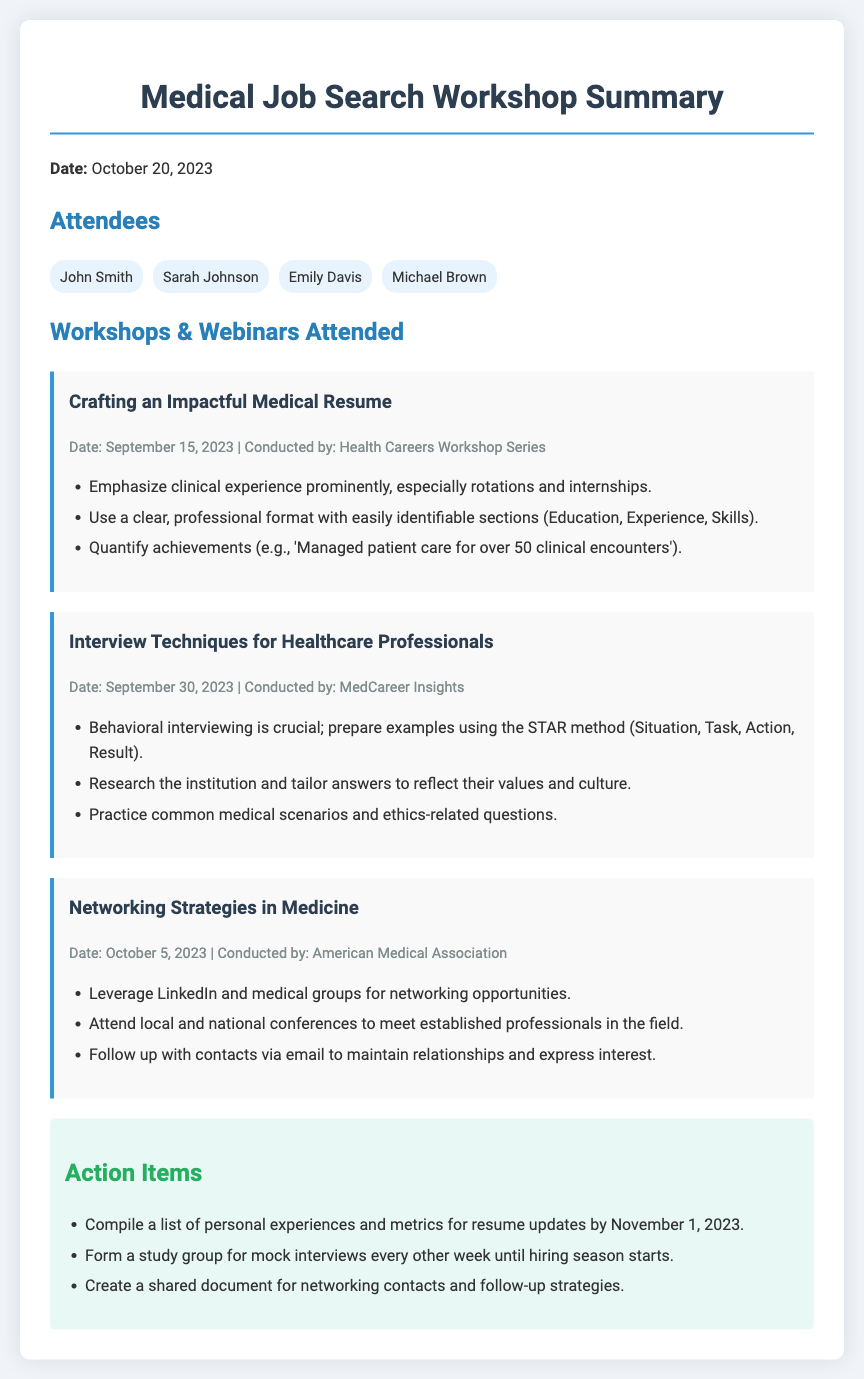What is the date of the workshop summary? The date is explicitly stated at the beginning of the document, which is October 20, 2023.
Answer: October 20, 2023 Who conducted the "Crafting an Impactful Medical Resume" workshop? The document specifies the organization that conducted this workshop as the Health Careers Workshop Series.
Answer: Health Careers Workshop Series What is one key takeaway from the "Interview Techniques for Healthcare Professionals"? The document lists several key points from the workshop, one of which emphasizes the STAR method for behavioral interviewing.
Answer: STAR method How many workshops or webinars were attended according to the document? By counting the workshops listed, there are three workshops mentioned in the document.
Answer: Three What is one of the action items mentioned in the document? The action items section outlines specific tasks, one of which is to compile a list of personal experiences and metrics for resume updates.
Answer: Compile a list of personal experiences When was the "Networking Strategies in Medicine" workshop held? The date of this workshop is mentioned in the document, which is October 5, 2023.
Answer: October 5, 2023 What is the color of the attendees' badges in the document? The document describes the attendee section with a specific background color that is light blue.
Answer: Light blue What method is suggested for preparing for interviews in the healthcare field? The document mentions using the STAR method, which is a structured way of responding to behavioral interview questions.
Answer: STAR method 